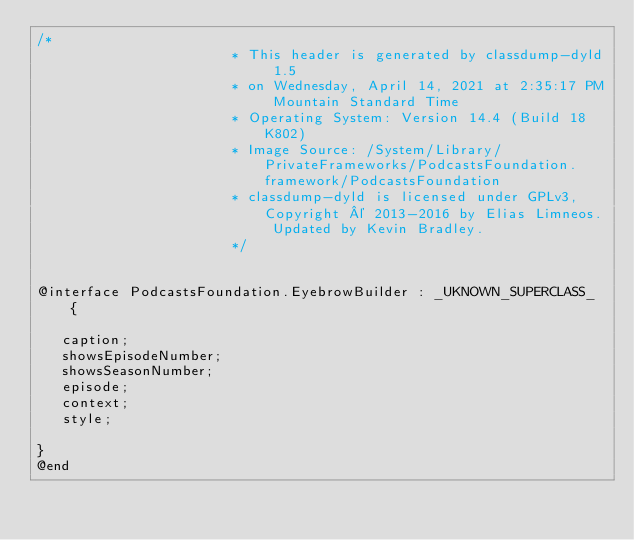<code> <loc_0><loc_0><loc_500><loc_500><_C_>/*
                       * This header is generated by classdump-dyld 1.5
                       * on Wednesday, April 14, 2021 at 2:35:17 PM Mountain Standard Time
                       * Operating System: Version 14.4 (Build 18K802)
                       * Image Source: /System/Library/PrivateFrameworks/PodcastsFoundation.framework/PodcastsFoundation
                       * classdump-dyld is licensed under GPLv3, Copyright © 2013-2016 by Elias Limneos. Updated by Kevin Bradley.
                       */


@interface PodcastsFoundation.EyebrowBuilder : _UKNOWN_SUPERCLASS_ {

	 caption;
	 showsEpisodeNumber;
	 showsSeasonNumber;
	 episode;
	 context;
	 style;

}
@end

</code> 